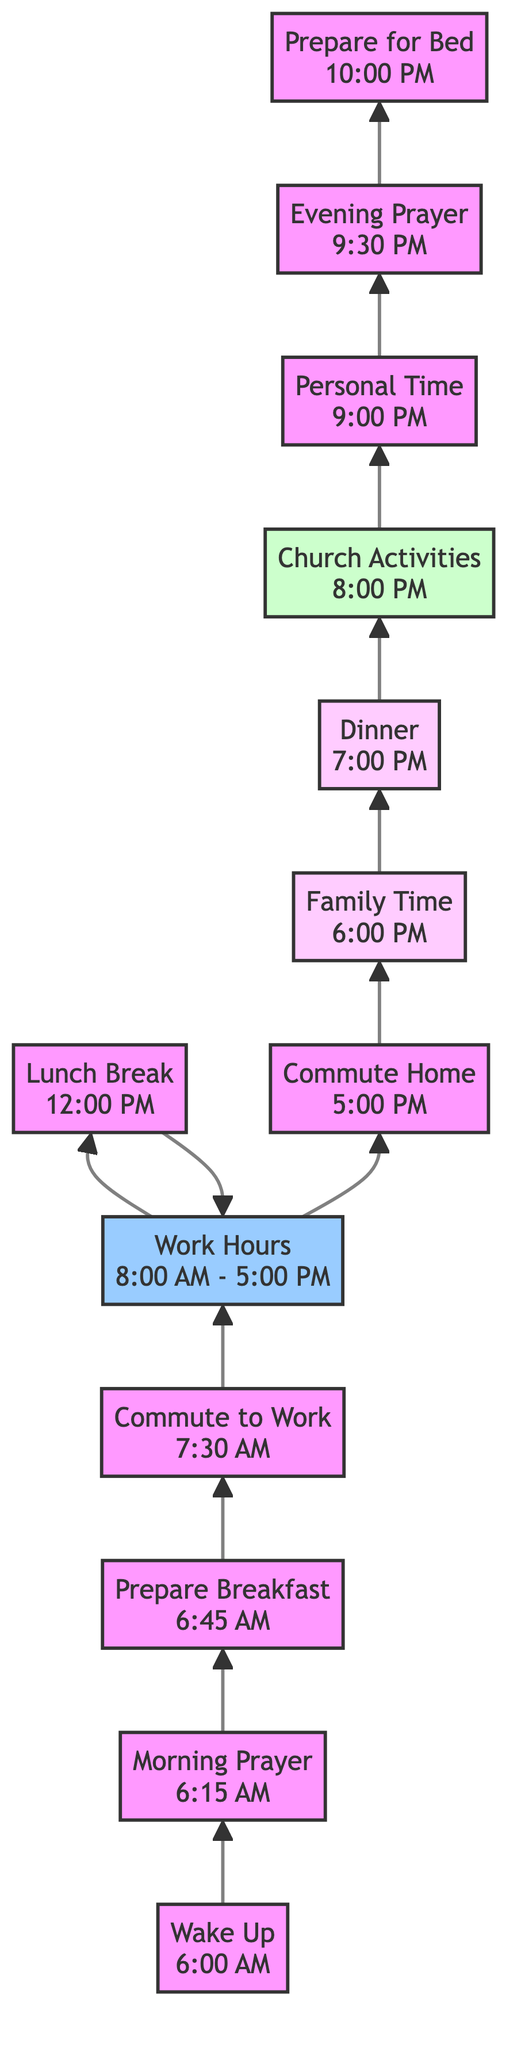What is the first activity of the day? The first node in the flow chart indicates the first activity is "Wake Up" at 6:00 AM.
Answer: Wake Up How long is the work hours period? The work hours node explicitly states the duration as "8:00 AM - 5:00 PM," making it a total of 9 hours.
Answer: 9 hours Which activity follows "Commute Home"? In the flow chart, the node directly above "Commute Home" is "Family Time," indicating that it is the next activity.
Answer: Family Time At what time does "Evening Prayer and Reflection" occur? The last activity in the flow chart up-flowing is "Evening Prayer and Reflection," which is noted as occurring at "9:30 PM."
Answer: 9:30 PM How many family-related activities are listed? The flow chart shows "Family Time" and "Dinner" as the two nodes specifically designated for family activities, totaling two family-related activities.
Answer: 2 What is the relationship between "Lunch Break" and "Work Hours"? "Lunch Break" is part of the flow between "Work Hours" and the workday, occurring between the work hours but not within them, as represented by the flow direction connecting these activities.
Answer: Part of the workday What activity takes place immediately after "Dinner"? The flow chart shows that "Church Activities" occurs right after "Dinner," representing the next scheduled activity in the day's routine.
Answer: Church Activities Which hour shows a transition from home to work? The "Commute to Work" activity clearly marks the time when transitioning from home to work and is indicated as occurring at "7:30 AM."
Answer: 7:30 AM Where does "Personal Time" fit in the daily routine? "Personal Time" is at the end of the flow, following the church activities and prior to the last activity of preparing for bed, showing it as part of the winding down of the daily routine.
Answer: After Church Activities 